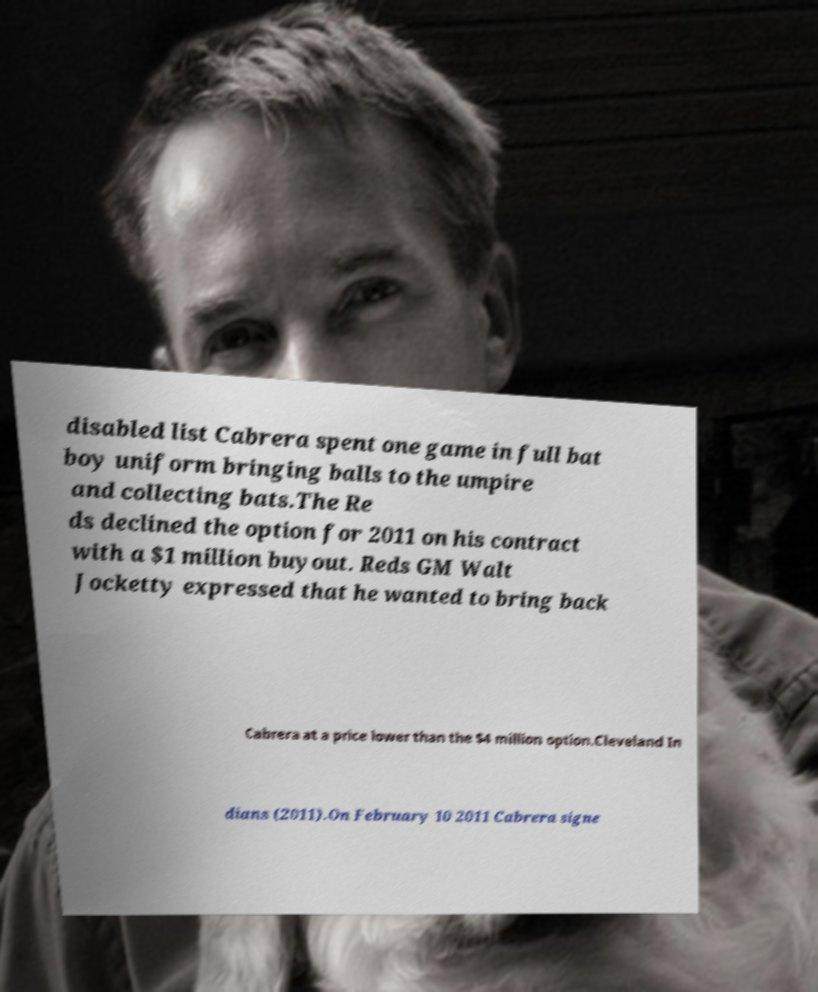I need the written content from this picture converted into text. Can you do that? disabled list Cabrera spent one game in full bat boy uniform bringing balls to the umpire and collecting bats.The Re ds declined the option for 2011 on his contract with a $1 million buyout. Reds GM Walt Jocketty expressed that he wanted to bring back Cabrera at a price lower than the $4 million option.Cleveland In dians (2011).On February 10 2011 Cabrera signe 